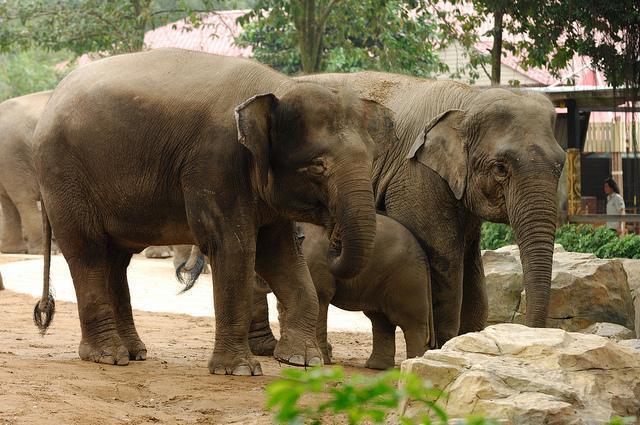How many elephants are there?
Give a very brief answer. 4. How many elephants are standing near the food?
Give a very brief answer. 3. 